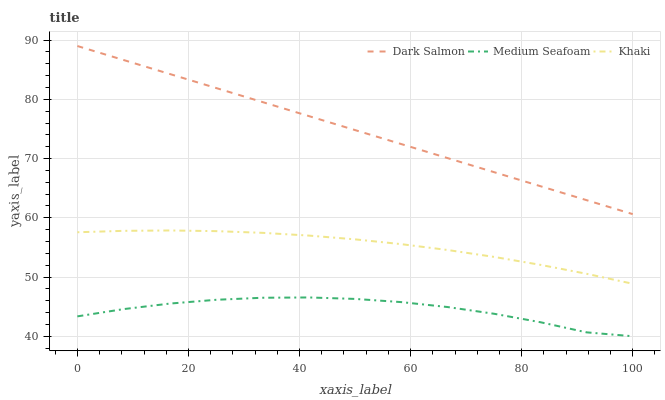Does Dark Salmon have the minimum area under the curve?
Answer yes or no. No. Does Medium Seafoam have the maximum area under the curve?
Answer yes or no. No. Is Medium Seafoam the smoothest?
Answer yes or no. No. Is Dark Salmon the roughest?
Answer yes or no. No. Does Dark Salmon have the lowest value?
Answer yes or no. No. Does Medium Seafoam have the highest value?
Answer yes or no. No. Is Khaki less than Dark Salmon?
Answer yes or no. Yes. Is Dark Salmon greater than Medium Seafoam?
Answer yes or no. Yes. Does Khaki intersect Dark Salmon?
Answer yes or no. No. 